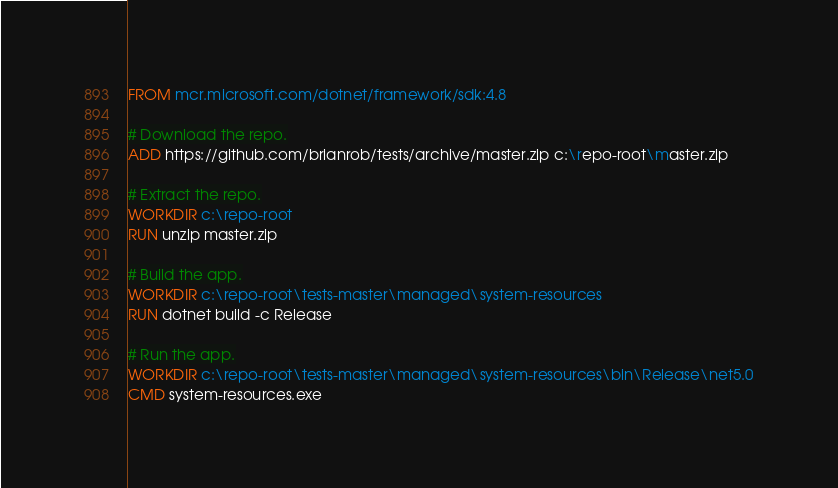<code> <loc_0><loc_0><loc_500><loc_500><_Dockerfile_>FROM mcr.microsoft.com/dotnet/framework/sdk:4.8

# Download the repo.
ADD https://github.com/brianrob/tests/archive/master.zip c:\repo-root\master.zip

# Extract the repo.
WORKDIR c:\repo-root
RUN unzip master.zip

# Build the app.
WORKDIR c:\repo-root\tests-master\managed\system-resources
RUN dotnet build -c Release

# Run the app.
WORKDIR c:\repo-root\tests-master\managed\system-resources\bin\Release\net5.0
CMD system-resources.exe
</code> 